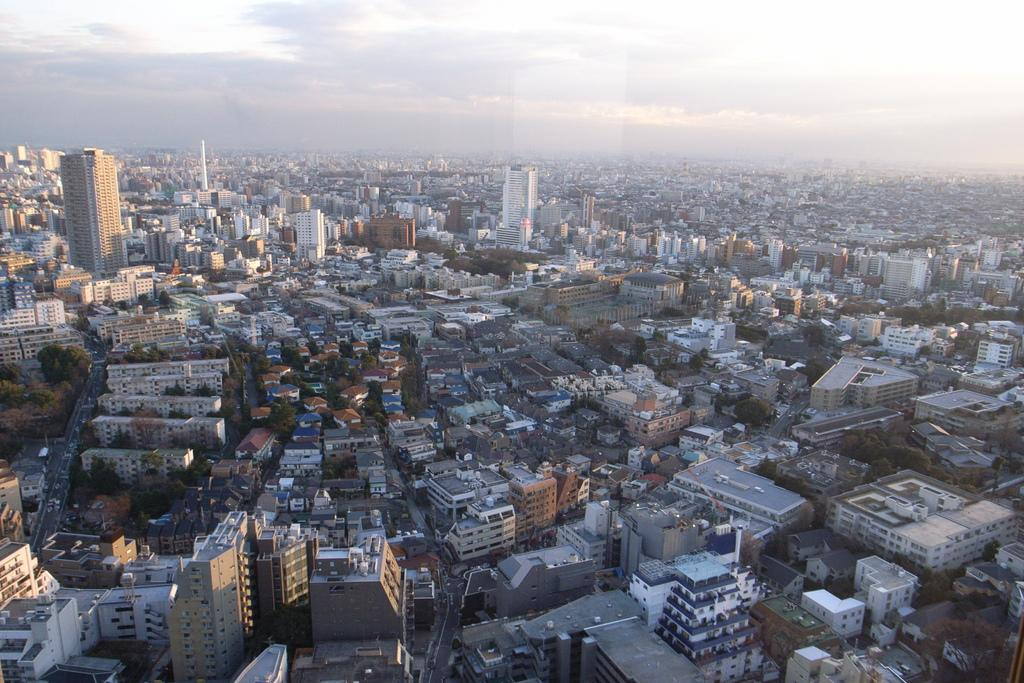What type of location is shown in the image? The image depicts a city. What structures can be seen in the city? There are many buildings and towers in the image. Are there any residential areas in the image? Yes, there are houses in the image. What type of vegetation is present between the houses? Trees are present between the houses in the image. What type of knife is being used by the trees in the image? There are no knives present in the image, and trees do not use knives. How many toes can be seen on the houses in the image? Houses do not have toes, so this question cannot be answered. 